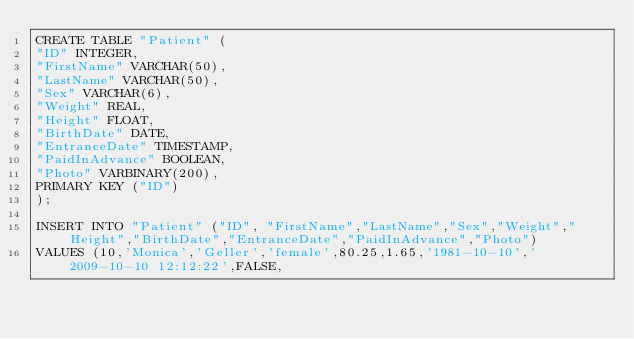<code> <loc_0><loc_0><loc_500><loc_500><_SQL_>CREATE TABLE "Patient" (
"ID" INTEGER,
"FirstName" VARCHAR(50),
"LastName" VARCHAR(50),
"Sex" VARCHAR(6),
"Weight" REAL,
"Height" FLOAT,
"BirthDate" DATE,
"EntranceDate" TIMESTAMP,
"PaidInAdvance" BOOLEAN,
"Photo" VARBINARY(200),
PRIMARY KEY ("ID")
);

INSERT INTO "Patient" ("ID", "FirstName","LastName","Sex","Weight","Height","BirthDate","EntranceDate","PaidInAdvance","Photo")
VALUES (10,'Monica','Geller','female',80.25,1.65,'1981-10-10','2009-10-10 12:12:22',FALSE,</code> 